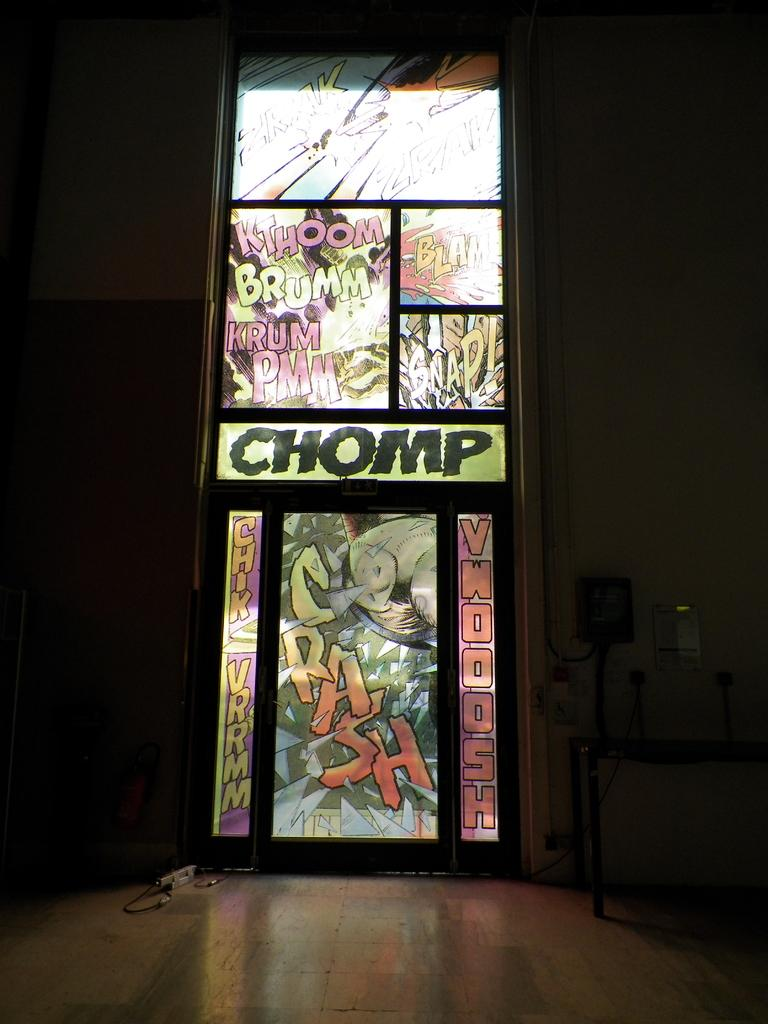What type of window is depicted in the image? There is a multi-color glass window in the image. How would you describe the lighting in the room in the image? The room is dark in the image. What is the size of the mint in the image? There is no mint present in the image. What type of education is being pursued by the people in the image? There are no people visible in the image, so it is impossible to determine their educational pursuits. 